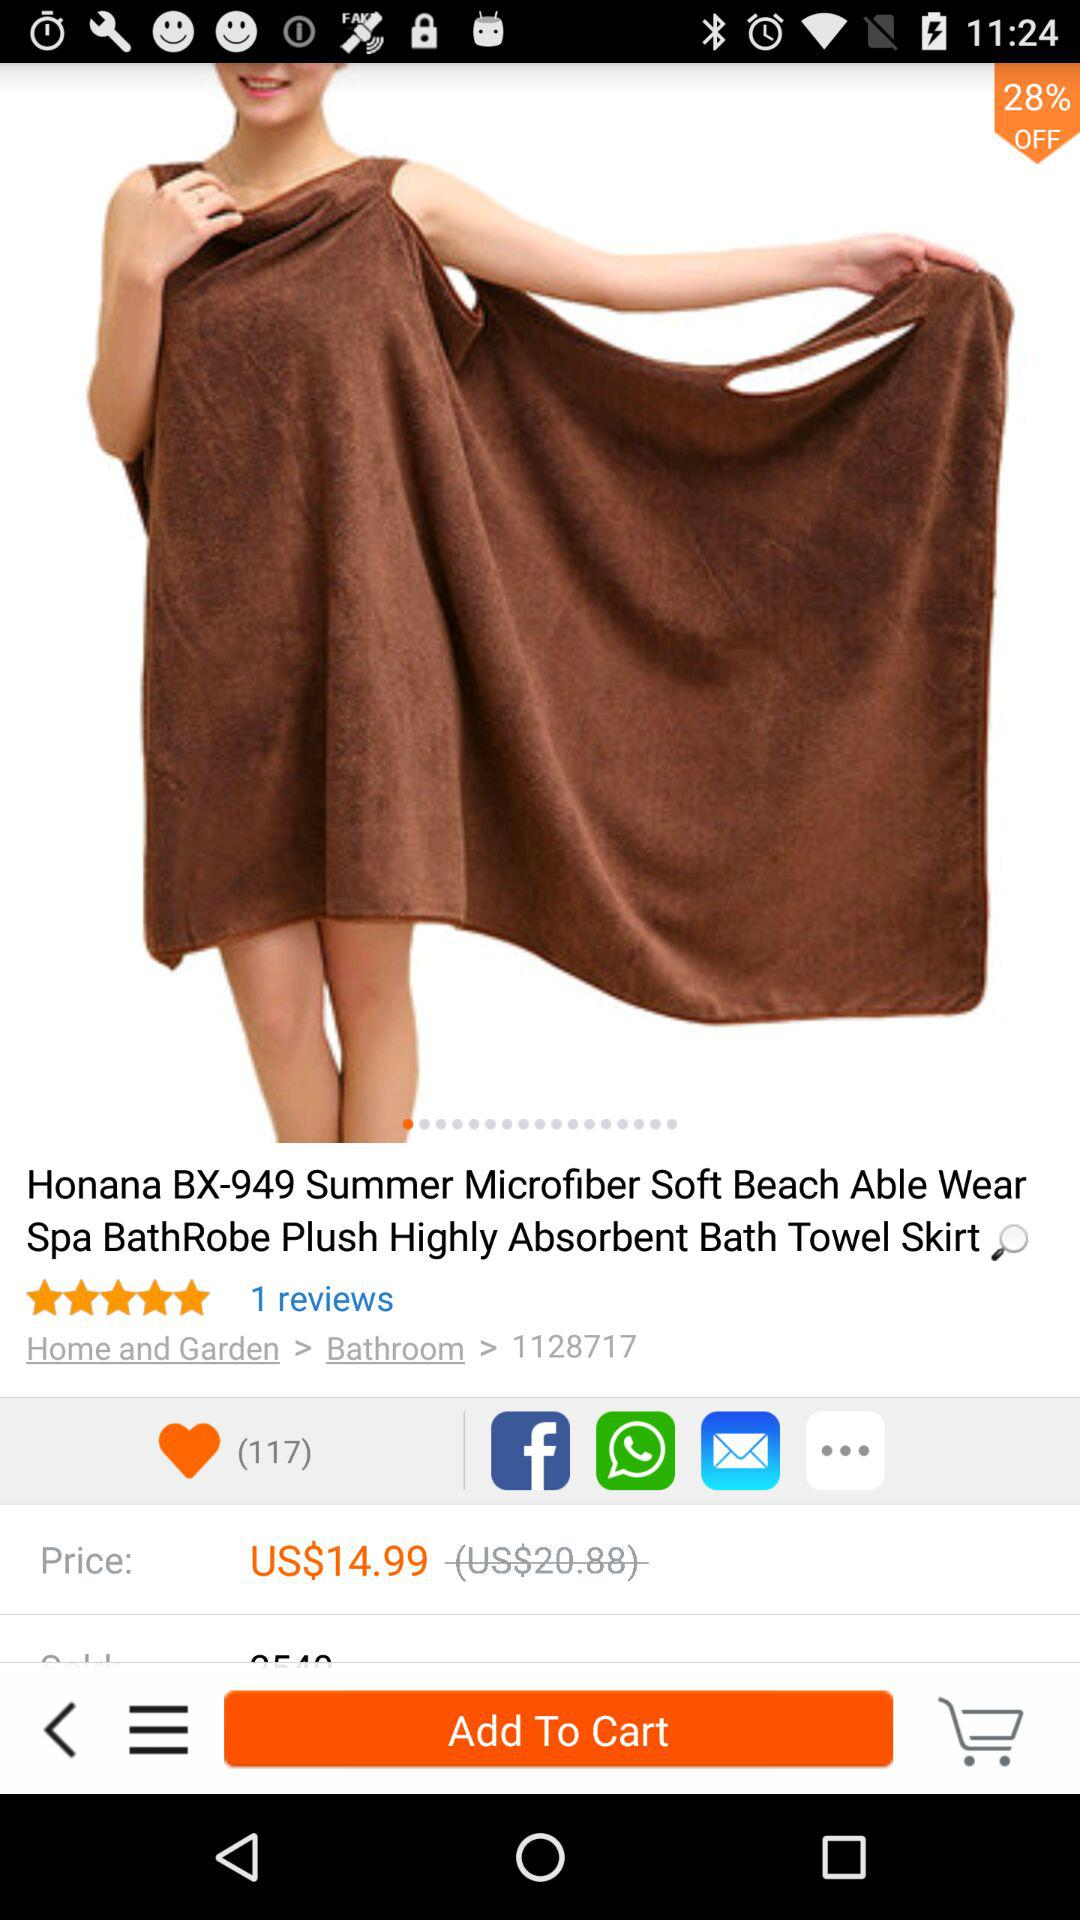What's the Number of likes?
When the provided information is insufficient, respond with <no answer>. <no answer> 